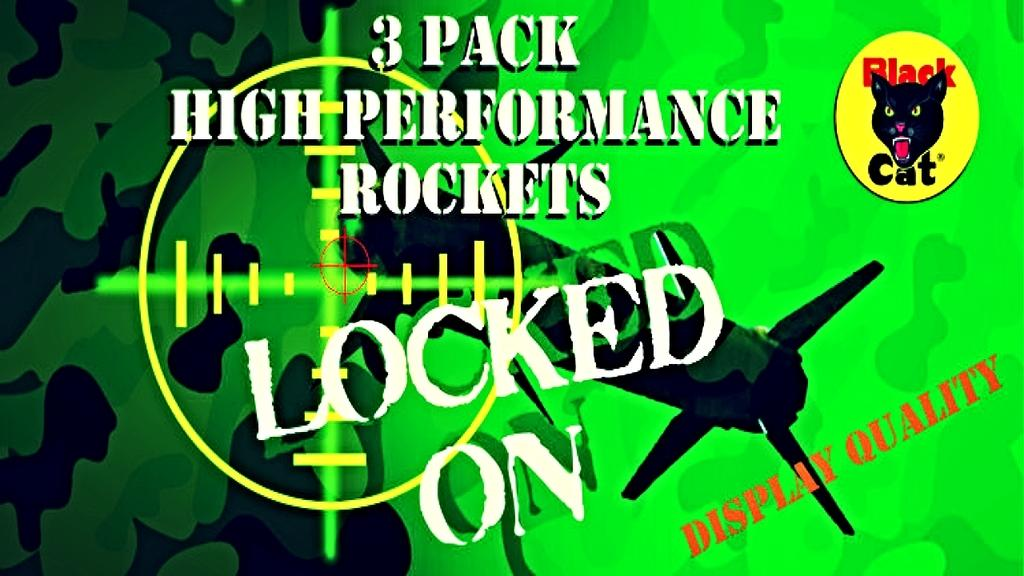What can be found in the image that contains written words? There is text in the image. What type of animal is depicted in the image? There is a cat face in the image. Where is the foot of the cat located in the image? There is no foot of the cat visible in the image; only the cat face is depicted. What type of furniture can be seen in the bedroom in the image? There is no bedroom or furniture present in the image; it only contains text and a cat face. 